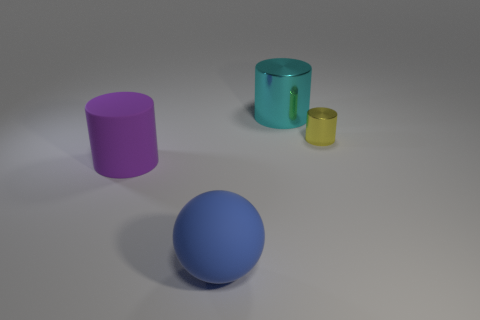Add 3 large purple matte cylinders. How many objects exist? 7 Subtract all balls. How many objects are left? 3 Subtract 1 purple cylinders. How many objects are left? 3 Subtract all large blue objects. Subtract all blue balls. How many objects are left? 2 Add 2 large blue things. How many large blue things are left? 3 Add 3 matte objects. How many matte objects exist? 5 